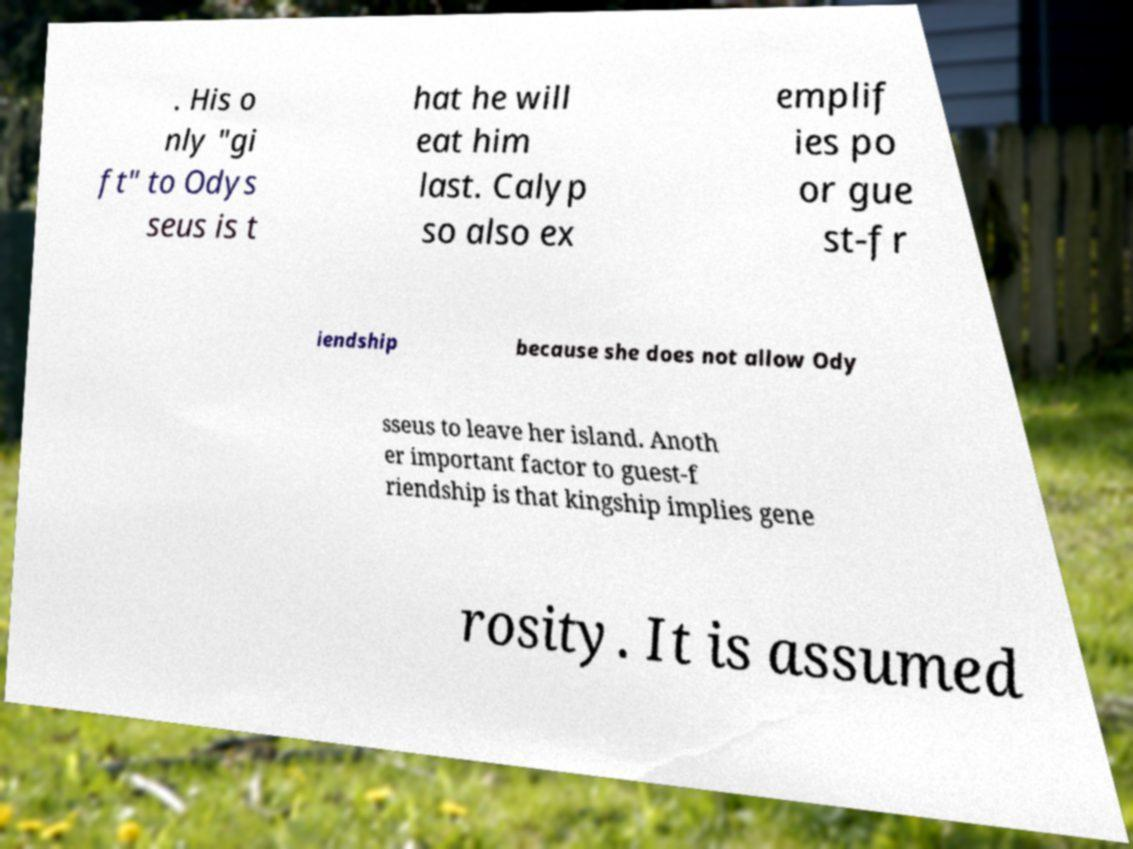Can you accurately transcribe the text from the provided image for me? . His o nly "gi ft" to Odys seus is t hat he will eat him last. Calyp so also ex emplif ies po or gue st-fr iendship because she does not allow Ody sseus to leave her island. Anoth er important factor to guest-f riendship is that kingship implies gene rosity. It is assumed 